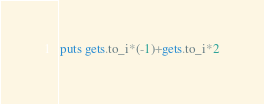<code> <loc_0><loc_0><loc_500><loc_500><_Ruby_>puts gets.to_i*(-1)+gets.to_i*2</code> 